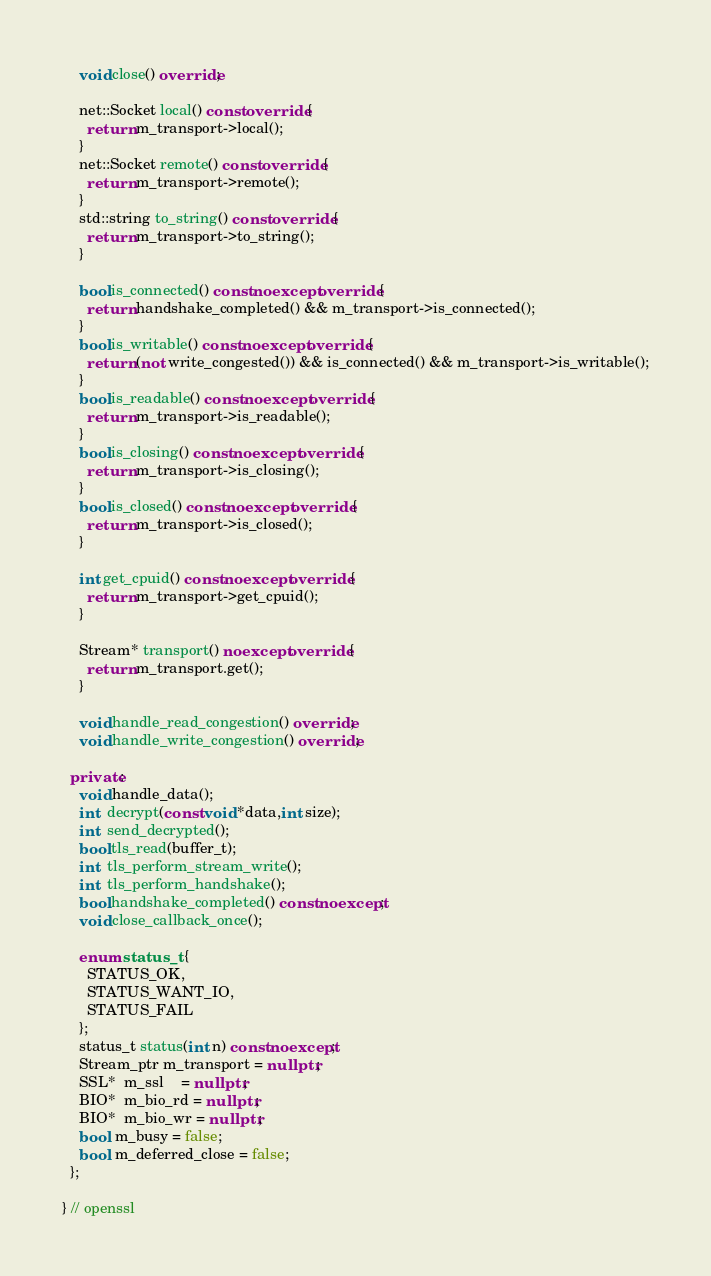Convert code to text. <code><loc_0><loc_0><loc_500><loc_500><_C++_>    void close() override;

    net::Socket local() const override {
      return m_transport->local();
    }
    net::Socket remote() const override {
      return m_transport->remote();
    }
    std::string to_string() const override {
      return m_transport->to_string();
    }

    bool is_connected() const noexcept override {
      return handshake_completed() && m_transport->is_connected();
    }
    bool is_writable() const noexcept override {
      return (not write_congested()) && is_connected() && m_transport->is_writable();
    }
    bool is_readable() const noexcept override {
      return m_transport->is_readable();
    }
    bool is_closing() const noexcept override {
      return m_transport->is_closing();
    }
    bool is_closed() const noexcept override {
      return m_transport->is_closed();
    }

    int get_cpuid() const noexcept override {
      return m_transport->get_cpuid();
    }

    Stream* transport() noexcept override {
      return m_transport.get();
    }

    void handle_read_congestion() override;
    void handle_write_congestion() override;

  private:
    void handle_data();
    int  decrypt(const void *data,int size);
    int  send_decrypted();
    bool tls_read(buffer_t);
    int  tls_perform_stream_write();
    int  tls_perform_handshake();
    bool handshake_completed() const noexcept;
    void close_callback_once();

    enum status_t {
      STATUS_OK,
      STATUS_WANT_IO,
      STATUS_FAIL
    };
    status_t status(int n) const noexcept;
    Stream_ptr m_transport = nullptr;
    SSL*  m_ssl    = nullptr;
    BIO*  m_bio_rd = nullptr;
    BIO*  m_bio_wr = nullptr;
    bool  m_busy = false;
    bool  m_deferred_close = false;
  };

} // openssl
</code> 